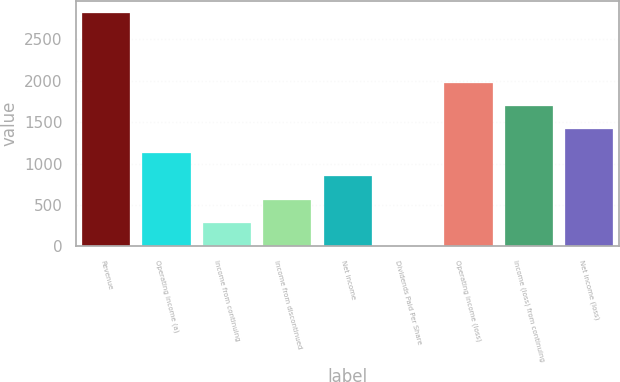Convert chart to OTSL. <chart><loc_0><loc_0><loc_500><loc_500><bar_chart><fcel>Revenue<fcel>Operating income (a)<fcel>Income from continuing<fcel>Income from discontinued<fcel>Net income<fcel>Dividends Paid Per Share<fcel>Operating income (loss)<fcel>Income (loss) from continuing<fcel>Net income (loss)<nl><fcel>2826<fcel>1130.49<fcel>282.75<fcel>565.33<fcel>847.91<fcel>0.17<fcel>1978.23<fcel>1695.65<fcel>1413.07<nl></chart> 